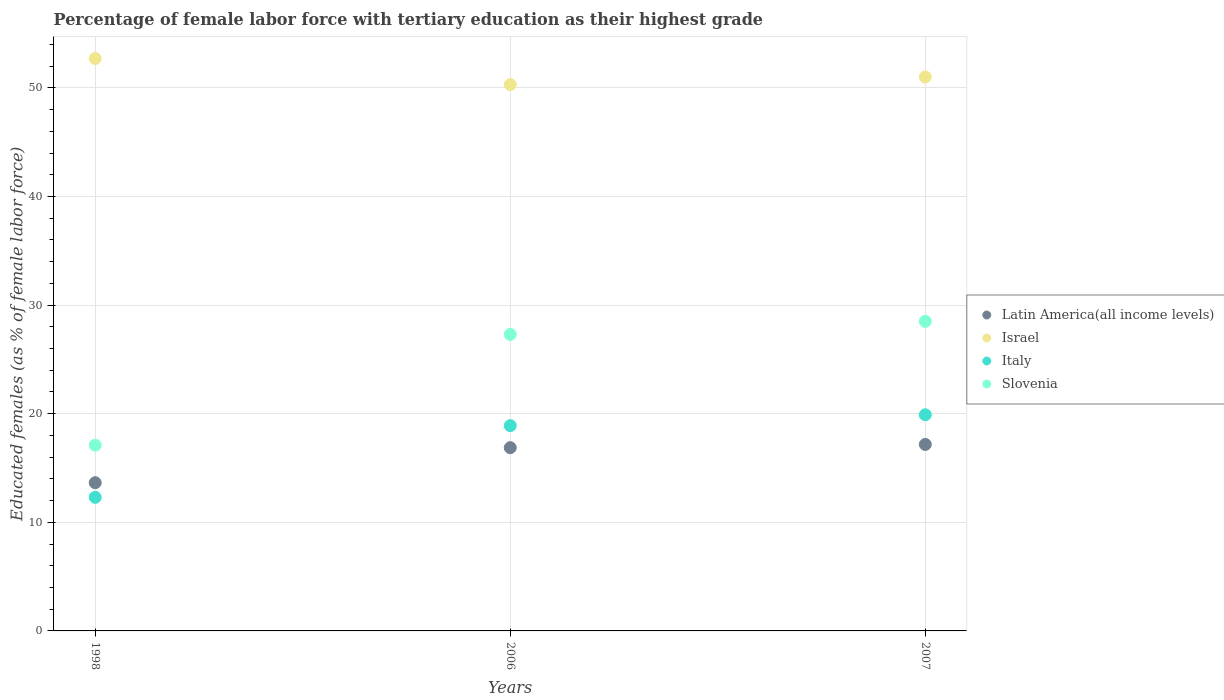What is the percentage of female labor force with tertiary education in Slovenia in 2006?
Offer a terse response. 27.3. Across all years, what is the maximum percentage of female labor force with tertiary education in Italy?
Make the answer very short. 19.9. Across all years, what is the minimum percentage of female labor force with tertiary education in Italy?
Provide a short and direct response. 12.3. In which year was the percentage of female labor force with tertiary education in Italy maximum?
Make the answer very short. 2007. What is the total percentage of female labor force with tertiary education in Israel in the graph?
Give a very brief answer. 154. What is the difference between the percentage of female labor force with tertiary education in Italy in 2006 and that in 2007?
Offer a very short reply. -1. What is the difference between the percentage of female labor force with tertiary education in Italy in 2006 and the percentage of female labor force with tertiary education in Israel in 1998?
Make the answer very short. -33.8. What is the average percentage of female labor force with tertiary education in Italy per year?
Make the answer very short. 17.03. In the year 1998, what is the difference between the percentage of female labor force with tertiary education in Israel and percentage of female labor force with tertiary education in Slovenia?
Provide a succinct answer. 35.6. What is the ratio of the percentage of female labor force with tertiary education in Italy in 1998 to that in 2006?
Make the answer very short. 0.65. Is the difference between the percentage of female labor force with tertiary education in Israel in 1998 and 2006 greater than the difference between the percentage of female labor force with tertiary education in Slovenia in 1998 and 2006?
Give a very brief answer. Yes. What is the difference between the highest and the second highest percentage of female labor force with tertiary education in Latin America(all income levels)?
Your response must be concise. 0.3. What is the difference between the highest and the lowest percentage of female labor force with tertiary education in Italy?
Keep it short and to the point. 7.6. In how many years, is the percentage of female labor force with tertiary education in Slovenia greater than the average percentage of female labor force with tertiary education in Slovenia taken over all years?
Provide a short and direct response. 2. Is it the case that in every year, the sum of the percentage of female labor force with tertiary education in Slovenia and percentage of female labor force with tertiary education in Italy  is greater than the sum of percentage of female labor force with tertiary education in Latin America(all income levels) and percentage of female labor force with tertiary education in Israel?
Your answer should be very brief. No. Is it the case that in every year, the sum of the percentage of female labor force with tertiary education in Italy and percentage of female labor force with tertiary education in Israel  is greater than the percentage of female labor force with tertiary education in Slovenia?
Offer a terse response. Yes. Does the percentage of female labor force with tertiary education in Israel monotonically increase over the years?
Ensure brevity in your answer.  No. How many dotlines are there?
Provide a short and direct response. 4. How many years are there in the graph?
Your response must be concise. 3. Does the graph contain any zero values?
Offer a terse response. No. Where does the legend appear in the graph?
Make the answer very short. Center right. How many legend labels are there?
Your answer should be compact. 4. How are the legend labels stacked?
Give a very brief answer. Vertical. What is the title of the graph?
Offer a very short reply. Percentage of female labor force with tertiary education as their highest grade. What is the label or title of the X-axis?
Provide a succinct answer. Years. What is the label or title of the Y-axis?
Your answer should be very brief. Educated females (as % of female labor force). What is the Educated females (as % of female labor force) of Latin America(all income levels) in 1998?
Your answer should be very brief. 13.65. What is the Educated females (as % of female labor force) in Israel in 1998?
Your answer should be compact. 52.7. What is the Educated females (as % of female labor force) of Italy in 1998?
Your answer should be compact. 12.3. What is the Educated females (as % of female labor force) of Slovenia in 1998?
Your response must be concise. 17.1. What is the Educated females (as % of female labor force) in Latin America(all income levels) in 2006?
Offer a terse response. 16.87. What is the Educated females (as % of female labor force) in Israel in 2006?
Provide a succinct answer. 50.3. What is the Educated females (as % of female labor force) of Italy in 2006?
Your answer should be very brief. 18.9. What is the Educated females (as % of female labor force) of Slovenia in 2006?
Your answer should be compact. 27.3. What is the Educated females (as % of female labor force) of Latin America(all income levels) in 2007?
Make the answer very short. 17.17. What is the Educated females (as % of female labor force) in Italy in 2007?
Your answer should be compact. 19.9. Across all years, what is the maximum Educated females (as % of female labor force) in Latin America(all income levels)?
Provide a succinct answer. 17.17. Across all years, what is the maximum Educated females (as % of female labor force) in Israel?
Offer a very short reply. 52.7. Across all years, what is the maximum Educated females (as % of female labor force) of Italy?
Keep it short and to the point. 19.9. Across all years, what is the minimum Educated females (as % of female labor force) in Latin America(all income levels)?
Your response must be concise. 13.65. Across all years, what is the minimum Educated females (as % of female labor force) of Israel?
Give a very brief answer. 50.3. Across all years, what is the minimum Educated females (as % of female labor force) of Italy?
Your answer should be very brief. 12.3. Across all years, what is the minimum Educated females (as % of female labor force) of Slovenia?
Offer a very short reply. 17.1. What is the total Educated females (as % of female labor force) of Latin America(all income levels) in the graph?
Your answer should be very brief. 47.69. What is the total Educated females (as % of female labor force) in Israel in the graph?
Make the answer very short. 154. What is the total Educated females (as % of female labor force) in Italy in the graph?
Keep it short and to the point. 51.1. What is the total Educated females (as % of female labor force) in Slovenia in the graph?
Your answer should be compact. 72.9. What is the difference between the Educated females (as % of female labor force) of Latin America(all income levels) in 1998 and that in 2006?
Provide a short and direct response. -3.22. What is the difference between the Educated females (as % of female labor force) of Slovenia in 1998 and that in 2006?
Your answer should be compact. -10.2. What is the difference between the Educated females (as % of female labor force) in Latin America(all income levels) in 1998 and that in 2007?
Offer a very short reply. -3.52. What is the difference between the Educated females (as % of female labor force) of Italy in 1998 and that in 2007?
Provide a short and direct response. -7.6. What is the difference between the Educated females (as % of female labor force) in Slovenia in 1998 and that in 2007?
Provide a succinct answer. -11.4. What is the difference between the Educated females (as % of female labor force) in Latin America(all income levels) in 2006 and that in 2007?
Your answer should be very brief. -0.3. What is the difference between the Educated females (as % of female labor force) in Italy in 2006 and that in 2007?
Offer a very short reply. -1. What is the difference between the Educated females (as % of female labor force) of Latin America(all income levels) in 1998 and the Educated females (as % of female labor force) of Israel in 2006?
Your response must be concise. -36.65. What is the difference between the Educated females (as % of female labor force) of Latin America(all income levels) in 1998 and the Educated females (as % of female labor force) of Italy in 2006?
Offer a terse response. -5.25. What is the difference between the Educated females (as % of female labor force) in Latin America(all income levels) in 1998 and the Educated females (as % of female labor force) in Slovenia in 2006?
Provide a short and direct response. -13.65. What is the difference between the Educated females (as % of female labor force) of Israel in 1998 and the Educated females (as % of female labor force) of Italy in 2006?
Offer a very short reply. 33.8. What is the difference between the Educated females (as % of female labor force) of Israel in 1998 and the Educated females (as % of female labor force) of Slovenia in 2006?
Your response must be concise. 25.4. What is the difference between the Educated females (as % of female labor force) of Latin America(all income levels) in 1998 and the Educated females (as % of female labor force) of Israel in 2007?
Ensure brevity in your answer.  -37.35. What is the difference between the Educated females (as % of female labor force) in Latin America(all income levels) in 1998 and the Educated females (as % of female labor force) in Italy in 2007?
Your response must be concise. -6.25. What is the difference between the Educated females (as % of female labor force) of Latin America(all income levels) in 1998 and the Educated females (as % of female labor force) of Slovenia in 2007?
Give a very brief answer. -14.85. What is the difference between the Educated females (as % of female labor force) in Israel in 1998 and the Educated females (as % of female labor force) in Italy in 2007?
Keep it short and to the point. 32.8. What is the difference between the Educated females (as % of female labor force) in Israel in 1998 and the Educated females (as % of female labor force) in Slovenia in 2007?
Your response must be concise. 24.2. What is the difference between the Educated females (as % of female labor force) in Italy in 1998 and the Educated females (as % of female labor force) in Slovenia in 2007?
Ensure brevity in your answer.  -16.2. What is the difference between the Educated females (as % of female labor force) of Latin America(all income levels) in 2006 and the Educated females (as % of female labor force) of Israel in 2007?
Your answer should be very brief. -34.13. What is the difference between the Educated females (as % of female labor force) of Latin America(all income levels) in 2006 and the Educated females (as % of female labor force) of Italy in 2007?
Provide a short and direct response. -3.03. What is the difference between the Educated females (as % of female labor force) in Latin America(all income levels) in 2006 and the Educated females (as % of female labor force) in Slovenia in 2007?
Offer a very short reply. -11.63. What is the difference between the Educated females (as % of female labor force) in Israel in 2006 and the Educated females (as % of female labor force) in Italy in 2007?
Ensure brevity in your answer.  30.4. What is the difference between the Educated females (as % of female labor force) in Israel in 2006 and the Educated females (as % of female labor force) in Slovenia in 2007?
Provide a short and direct response. 21.8. What is the average Educated females (as % of female labor force) of Latin America(all income levels) per year?
Provide a succinct answer. 15.9. What is the average Educated females (as % of female labor force) in Israel per year?
Ensure brevity in your answer.  51.33. What is the average Educated females (as % of female labor force) in Italy per year?
Ensure brevity in your answer.  17.03. What is the average Educated females (as % of female labor force) in Slovenia per year?
Offer a terse response. 24.3. In the year 1998, what is the difference between the Educated females (as % of female labor force) in Latin America(all income levels) and Educated females (as % of female labor force) in Israel?
Your response must be concise. -39.05. In the year 1998, what is the difference between the Educated females (as % of female labor force) of Latin America(all income levels) and Educated females (as % of female labor force) of Italy?
Keep it short and to the point. 1.35. In the year 1998, what is the difference between the Educated females (as % of female labor force) in Latin America(all income levels) and Educated females (as % of female labor force) in Slovenia?
Offer a very short reply. -3.45. In the year 1998, what is the difference between the Educated females (as % of female labor force) in Israel and Educated females (as % of female labor force) in Italy?
Keep it short and to the point. 40.4. In the year 1998, what is the difference between the Educated females (as % of female labor force) in Israel and Educated females (as % of female labor force) in Slovenia?
Offer a very short reply. 35.6. In the year 2006, what is the difference between the Educated females (as % of female labor force) of Latin America(all income levels) and Educated females (as % of female labor force) of Israel?
Give a very brief answer. -33.43. In the year 2006, what is the difference between the Educated females (as % of female labor force) in Latin America(all income levels) and Educated females (as % of female labor force) in Italy?
Provide a short and direct response. -2.03. In the year 2006, what is the difference between the Educated females (as % of female labor force) of Latin America(all income levels) and Educated females (as % of female labor force) of Slovenia?
Make the answer very short. -10.43. In the year 2006, what is the difference between the Educated females (as % of female labor force) in Israel and Educated females (as % of female labor force) in Italy?
Provide a short and direct response. 31.4. In the year 2006, what is the difference between the Educated females (as % of female labor force) in Israel and Educated females (as % of female labor force) in Slovenia?
Your response must be concise. 23. In the year 2007, what is the difference between the Educated females (as % of female labor force) in Latin America(all income levels) and Educated females (as % of female labor force) in Israel?
Offer a very short reply. -33.83. In the year 2007, what is the difference between the Educated females (as % of female labor force) in Latin America(all income levels) and Educated females (as % of female labor force) in Italy?
Offer a very short reply. -2.73. In the year 2007, what is the difference between the Educated females (as % of female labor force) of Latin America(all income levels) and Educated females (as % of female labor force) of Slovenia?
Your answer should be compact. -11.33. In the year 2007, what is the difference between the Educated females (as % of female labor force) in Israel and Educated females (as % of female labor force) in Italy?
Keep it short and to the point. 31.1. In the year 2007, what is the difference between the Educated females (as % of female labor force) of Italy and Educated females (as % of female labor force) of Slovenia?
Ensure brevity in your answer.  -8.6. What is the ratio of the Educated females (as % of female labor force) of Latin America(all income levels) in 1998 to that in 2006?
Provide a short and direct response. 0.81. What is the ratio of the Educated females (as % of female labor force) of Israel in 1998 to that in 2006?
Provide a succinct answer. 1.05. What is the ratio of the Educated females (as % of female labor force) in Italy in 1998 to that in 2006?
Ensure brevity in your answer.  0.65. What is the ratio of the Educated females (as % of female labor force) of Slovenia in 1998 to that in 2006?
Your response must be concise. 0.63. What is the ratio of the Educated females (as % of female labor force) in Latin America(all income levels) in 1998 to that in 2007?
Keep it short and to the point. 0.79. What is the ratio of the Educated females (as % of female labor force) of Italy in 1998 to that in 2007?
Offer a very short reply. 0.62. What is the ratio of the Educated females (as % of female labor force) of Latin America(all income levels) in 2006 to that in 2007?
Ensure brevity in your answer.  0.98. What is the ratio of the Educated females (as % of female labor force) in Israel in 2006 to that in 2007?
Give a very brief answer. 0.99. What is the ratio of the Educated females (as % of female labor force) in Italy in 2006 to that in 2007?
Give a very brief answer. 0.95. What is the ratio of the Educated females (as % of female labor force) in Slovenia in 2006 to that in 2007?
Your answer should be very brief. 0.96. What is the difference between the highest and the second highest Educated females (as % of female labor force) in Latin America(all income levels)?
Provide a succinct answer. 0.3. What is the difference between the highest and the second highest Educated females (as % of female labor force) of Italy?
Provide a succinct answer. 1. What is the difference between the highest and the lowest Educated females (as % of female labor force) in Latin America(all income levels)?
Make the answer very short. 3.52. What is the difference between the highest and the lowest Educated females (as % of female labor force) of Israel?
Your response must be concise. 2.4. What is the difference between the highest and the lowest Educated females (as % of female labor force) in Slovenia?
Offer a very short reply. 11.4. 